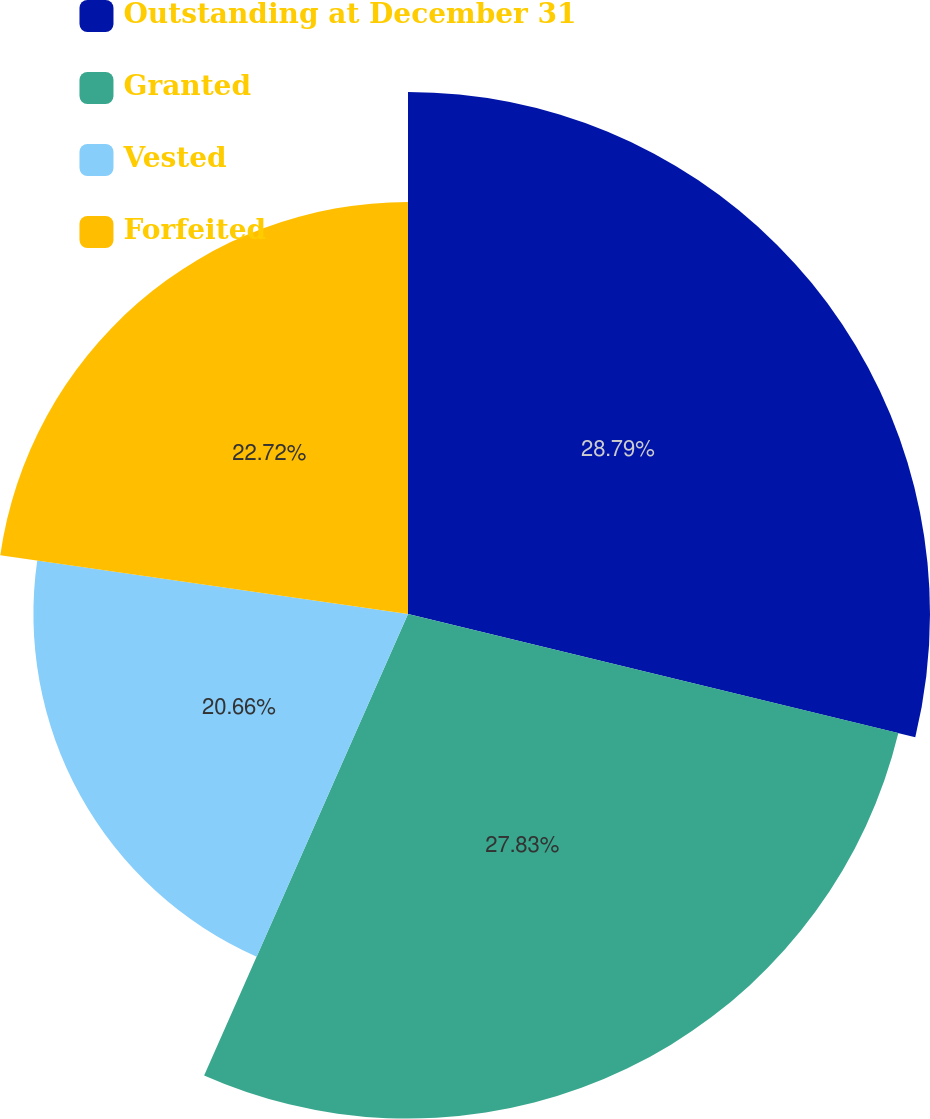<chart> <loc_0><loc_0><loc_500><loc_500><pie_chart><fcel>Outstanding at December 31<fcel>Granted<fcel>Vested<fcel>Forfeited<nl><fcel>28.79%<fcel>27.83%<fcel>20.66%<fcel>22.72%<nl></chart> 